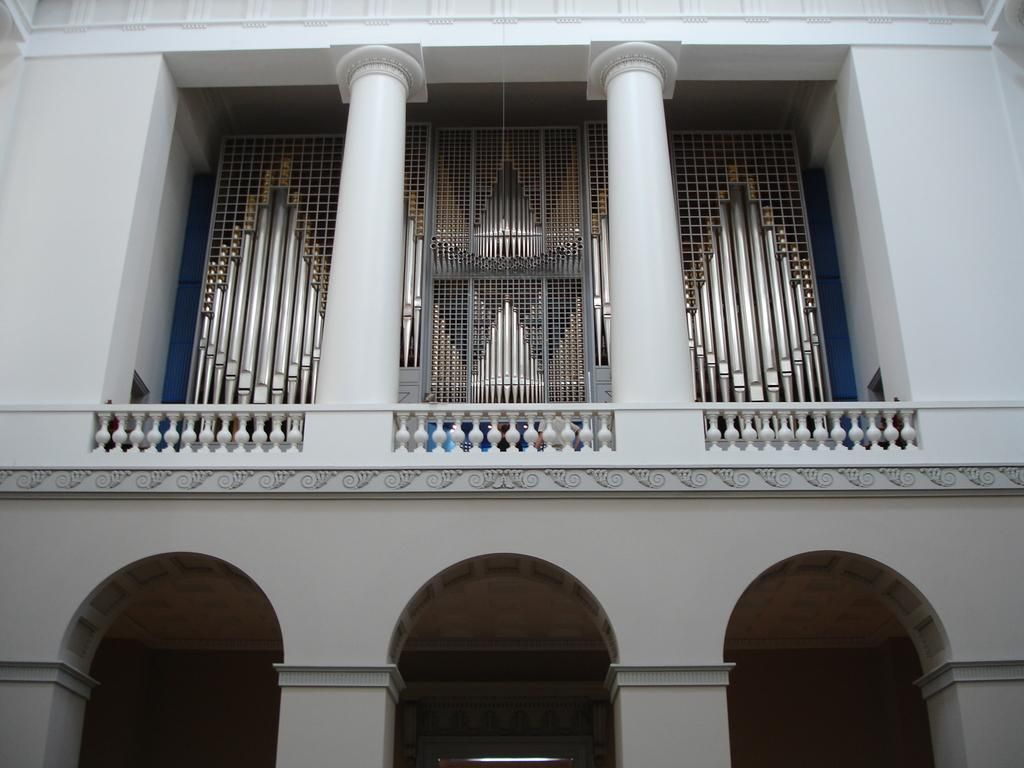What is the main subject in the center of the image? There is a building in the center of the image. What other objects can be seen in the image? There are rods and a mesh visible in the image. How many men are playing in the band in the image? There is no band or men present in the image; it only features a building, rods, and a mesh. 